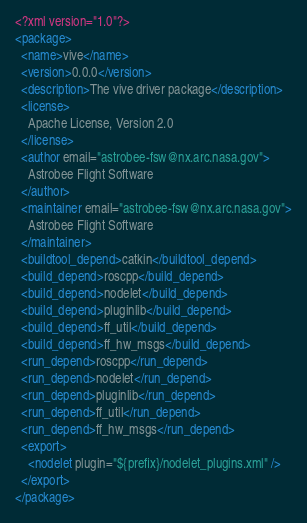<code> <loc_0><loc_0><loc_500><loc_500><_XML_><?xml version="1.0"?>
<package>
  <name>vive</name>
  <version>0.0.0</version>
  <description>The vive driver package</description>
  <license>
    Apache License, Version 2.0
  </license>
  <author email="astrobee-fsw@nx.arc.nasa.gov">
    Astrobee Flight Software
  </author>
  <maintainer email="astrobee-fsw@nx.arc.nasa.gov">
    Astrobee Flight Software
  </maintainer>
  <buildtool_depend>catkin</buildtool_depend>
  <build_depend>roscpp</build_depend>
  <build_depend>nodelet</build_depend>
  <build_depend>pluginlib</build_depend>
  <build_depend>ff_util</build_depend>
  <build_depend>ff_hw_msgs</build_depend>
  <run_depend>roscpp</run_depend>
  <run_depend>nodelet</run_depend>
  <run_depend>pluginlib</run_depend>
  <run_depend>ff_util</run_depend>
  <run_depend>ff_hw_msgs</run_depend>
  <export>
    <nodelet plugin="${prefix}/nodelet_plugins.xml" />
  </export>
</package>
</code> 